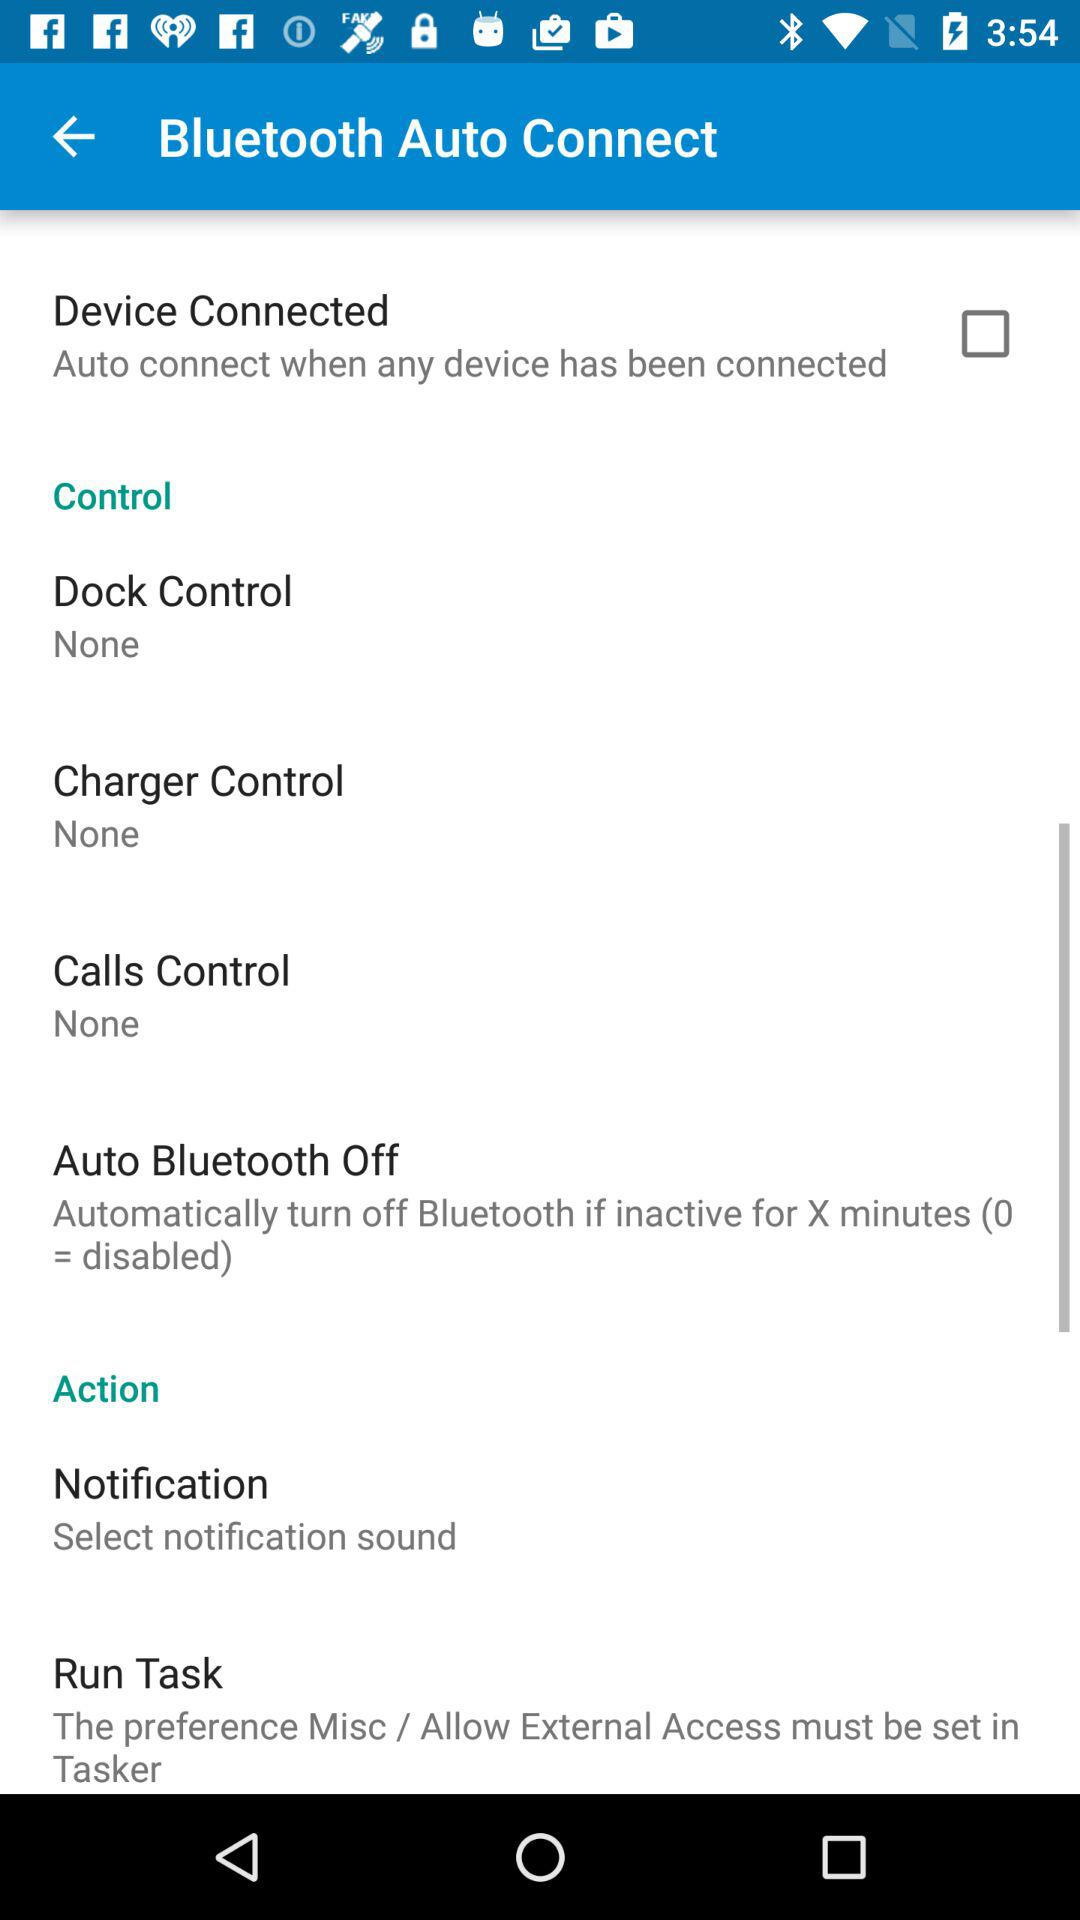What is the status of the "Device Connected"? The status is off. 